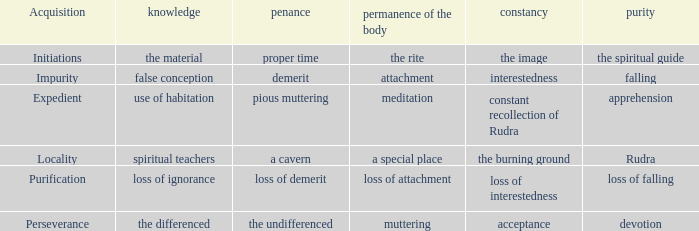 what's the permanence of the body where purity is apprehension Meditation. 